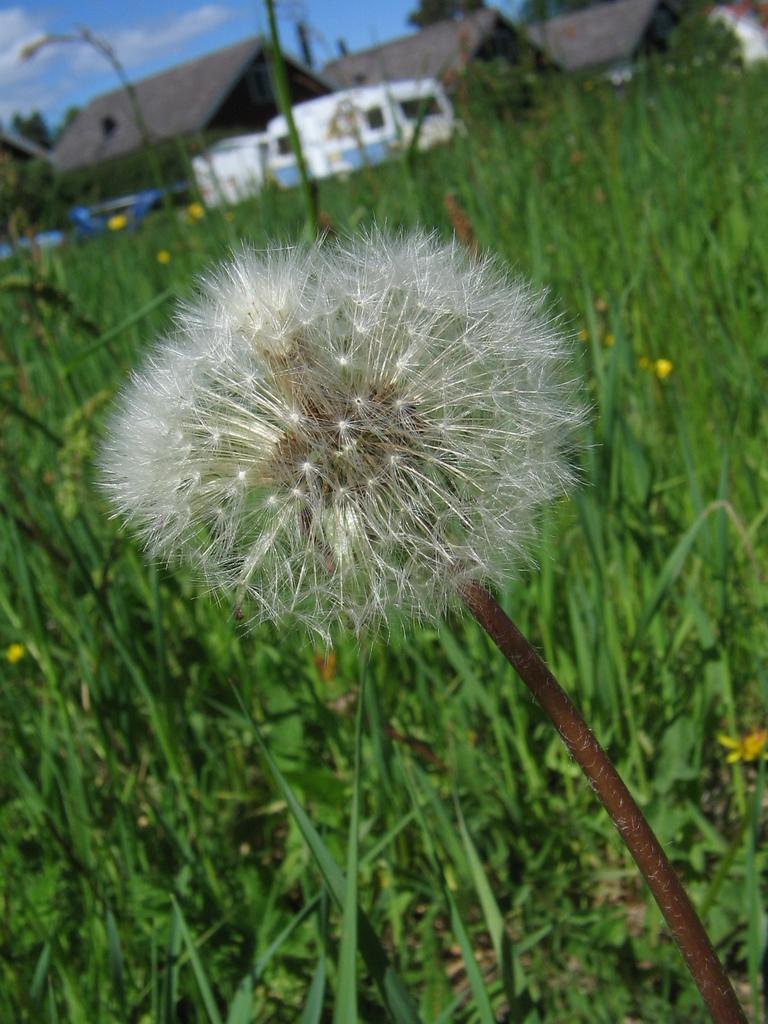Describe this image in one or two sentences. In this picture there is a flower at the bottom right. At the bottom there are plants. On the top there are buildings, trees and sky. 